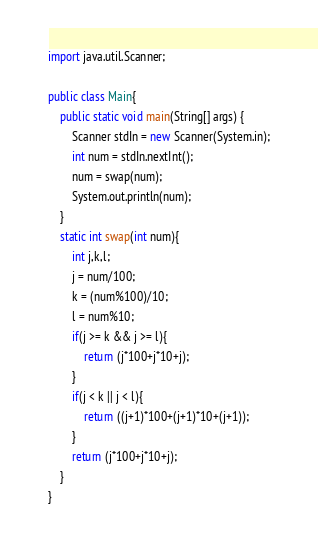<code> <loc_0><loc_0><loc_500><loc_500><_Java_>import java.util.Scanner;

public class Main{
    public static void main(String[] args) {
        Scanner stdIn = new Scanner(System.in);
        int num = stdIn.nextInt();
        num = swap(num);
        System.out.println(num);
    }
    static int swap(int num){
        int j,k,l;
        j = num/100;
        k = (num%100)/10;
        l = num%10;
        if(j >= k && j >= l){
            return (j*100+j*10+j);
        }
        if(j < k || j < l){
            return ((j+1)*100+(j+1)*10+(j+1));
        }
        return (j*100+j*10+j);
    }
}</code> 